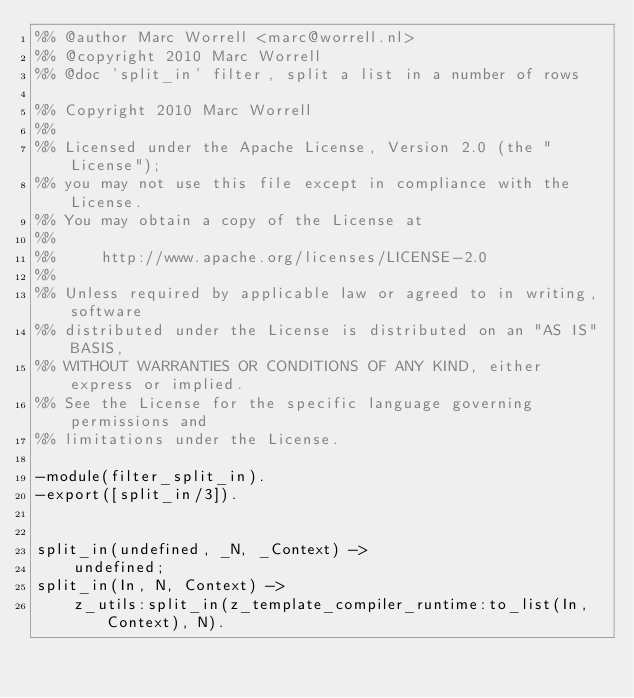<code> <loc_0><loc_0><loc_500><loc_500><_Erlang_>%% @author Marc Worrell <marc@worrell.nl>
%% @copyright 2010 Marc Worrell
%% @doc 'split_in' filter, split a list in a number of rows

%% Copyright 2010 Marc Worrell
%%
%% Licensed under the Apache License, Version 2.0 (the "License");
%% you may not use this file except in compliance with the License.
%% You may obtain a copy of the License at
%%
%%     http://www.apache.org/licenses/LICENSE-2.0
%%
%% Unless required by applicable law or agreed to in writing, software
%% distributed under the License is distributed on an "AS IS" BASIS,
%% WITHOUT WARRANTIES OR CONDITIONS OF ANY KIND, either express or implied.
%% See the License for the specific language governing permissions and
%% limitations under the License.

-module(filter_split_in).
-export([split_in/3]).


split_in(undefined, _N, _Context) ->
    undefined;
split_in(In, N, Context) ->
    z_utils:split_in(z_template_compiler_runtime:to_list(In, Context), N).
</code> 